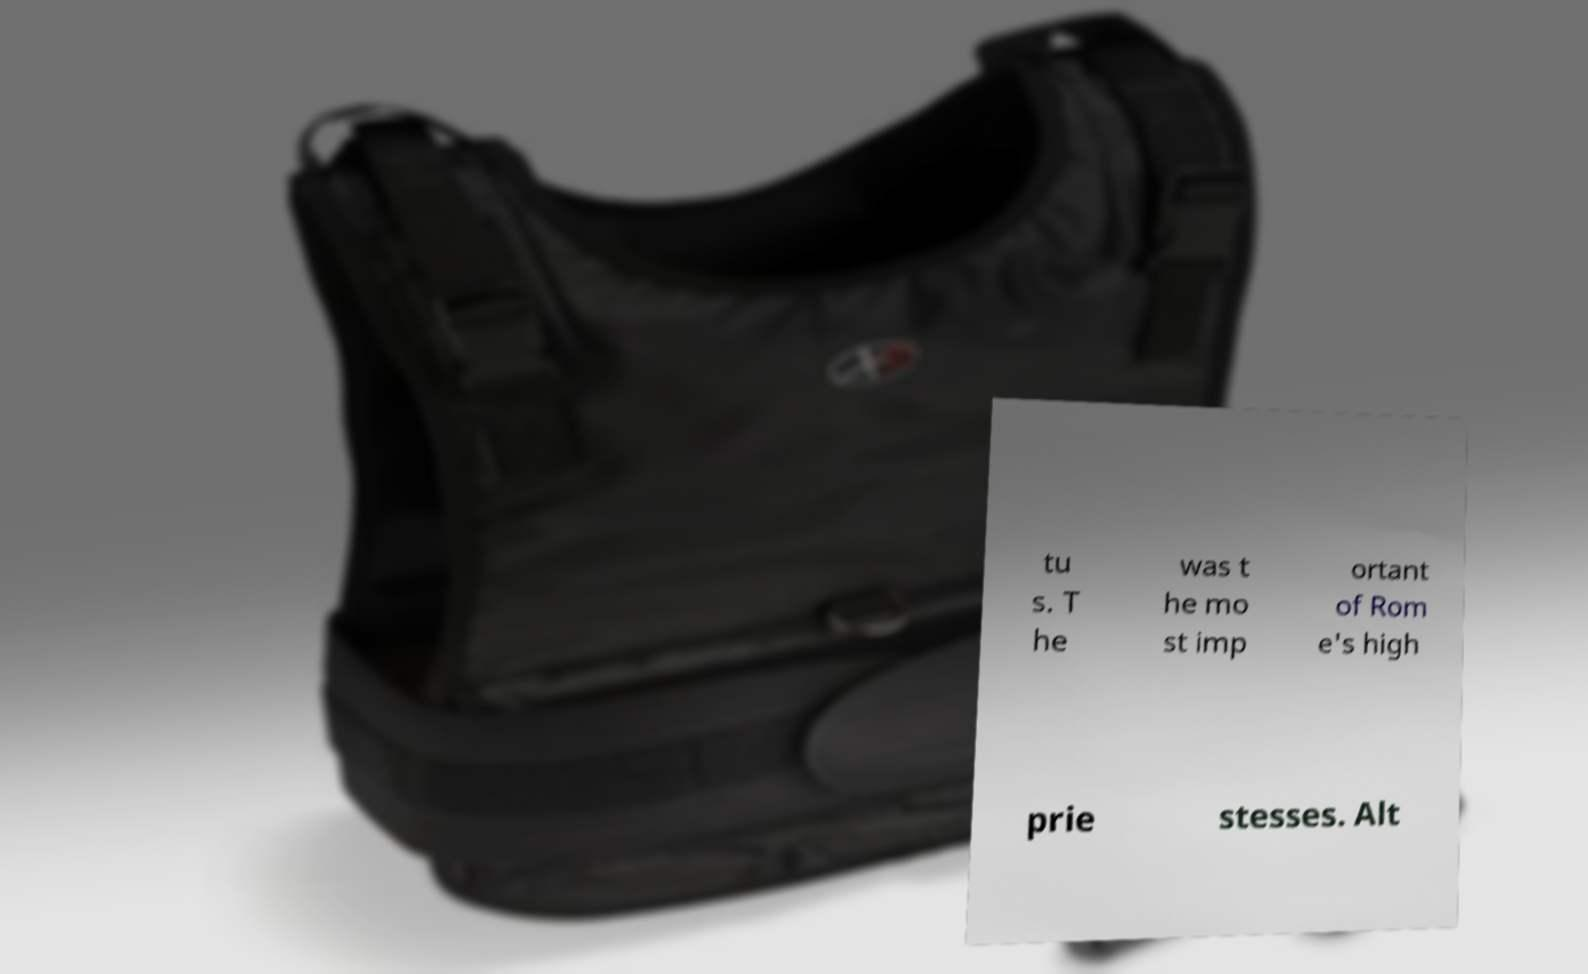What messages or text are displayed in this image? I need them in a readable, typed format. tu s. T he was t he mo st imp ortant of Rom e's high prie stesses. Alt 